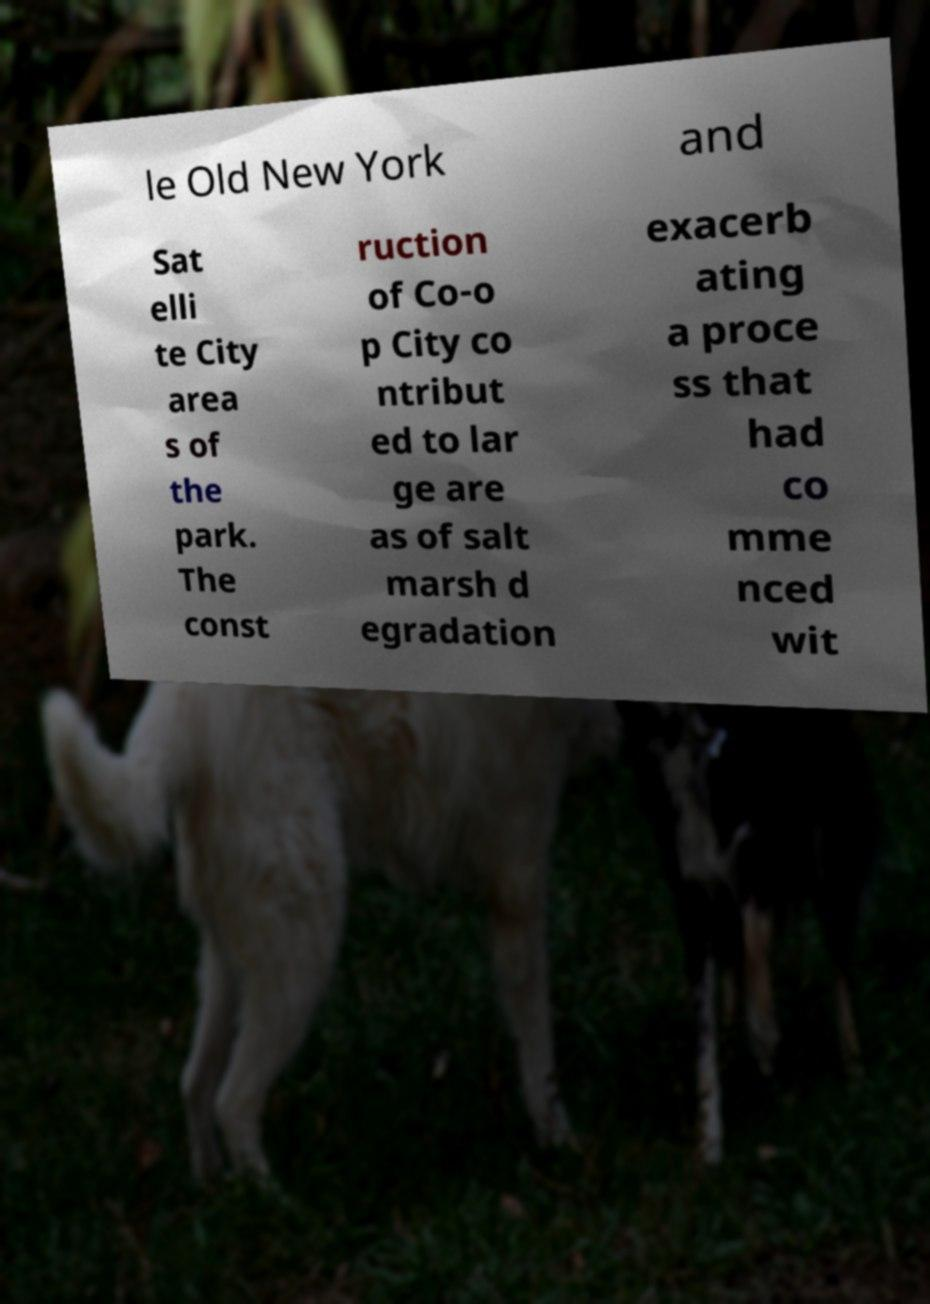There's text embedded in this image that I need extracted. Can you transcribe it verbatim? le Old New York and Sat elli te City area s of the park. The const ruction of Co-o p City co ntribut ed to lar ge are as of salt marsh d egradation exacerb ating a proce ss that had co mme nced wit 